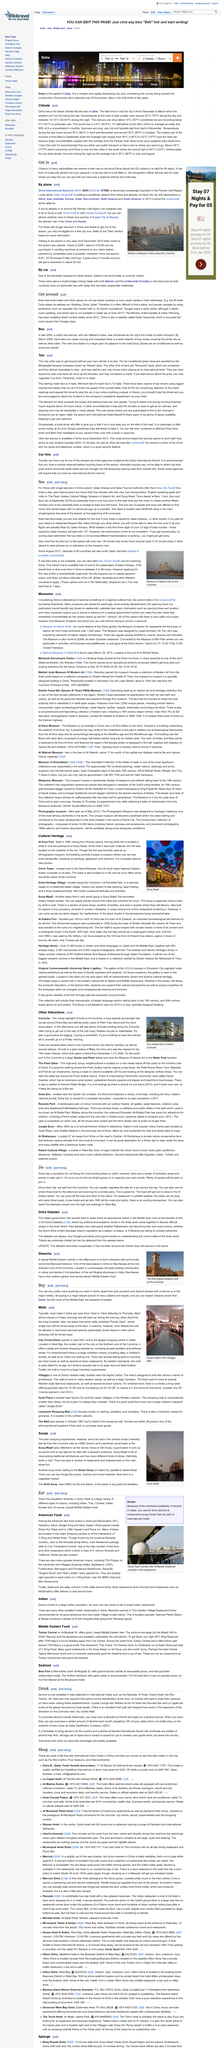Point out several critical features in this image. In the photograph, the statue of Orry stands proudly on Doha's Corniche. It is a fact that Doha's variety of cuisine includes both Indian and Chinese dishes. The typical hours of operation for most malls in Doha are from 10:00 AM to 10:00 PM, Saturday to Thursday. Tickets for the Doha Debates can be obtained via the website of the event's organizer. The dhow boat ride sets sail from the Corniche, which is a prominent waterfront location in Muscat, Oman. 